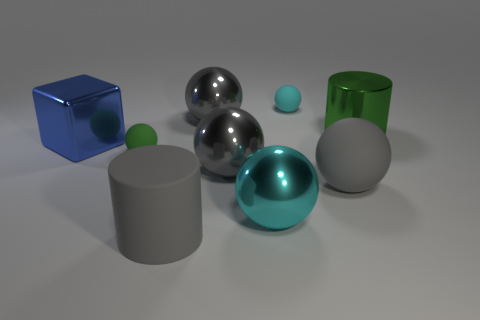There is a large thing that is made of the same material as the gray cylinder; what color is it?
Your answer should be very brief. Gray. Is there any other thing that is the same size as the shiny cylinder?
Your answer should be very brief. Yes. Does the large cylinder that is in front of the big cyan metallic object have the same color as the rubber ball that is on the right side of the cyan rubber ball?
Offer a terse response. Yes. Is the number of big gray shiny spheres that are behind the big green cylinder greater than the number of big gray rubber objects on the left side of the tiny green ball?
Your answer should be very brief. Yes. There is another tiny thing that is the same shape as the green rubber thing; what is its color?
Your response must be concise. Cyan. Are there any other things that have the same shape as the tiny green matte thing?
Your response must be concise. Yes. There is a big cyan metallic object; is it the same shape as the metal thing to the right of the small cyan matte object?
Provide a short and direct response. No. How many other things are there of the same material as the small cyan ball?
Your answer should be very brief. 3. Does the shiny cylinder have the same color as the big cylinder to the left of the big green thing?
Offer a terse response. No. There is a cyan ball in front of the small cyan ball; what is it made of?
Your answer should be compact. Metal. 